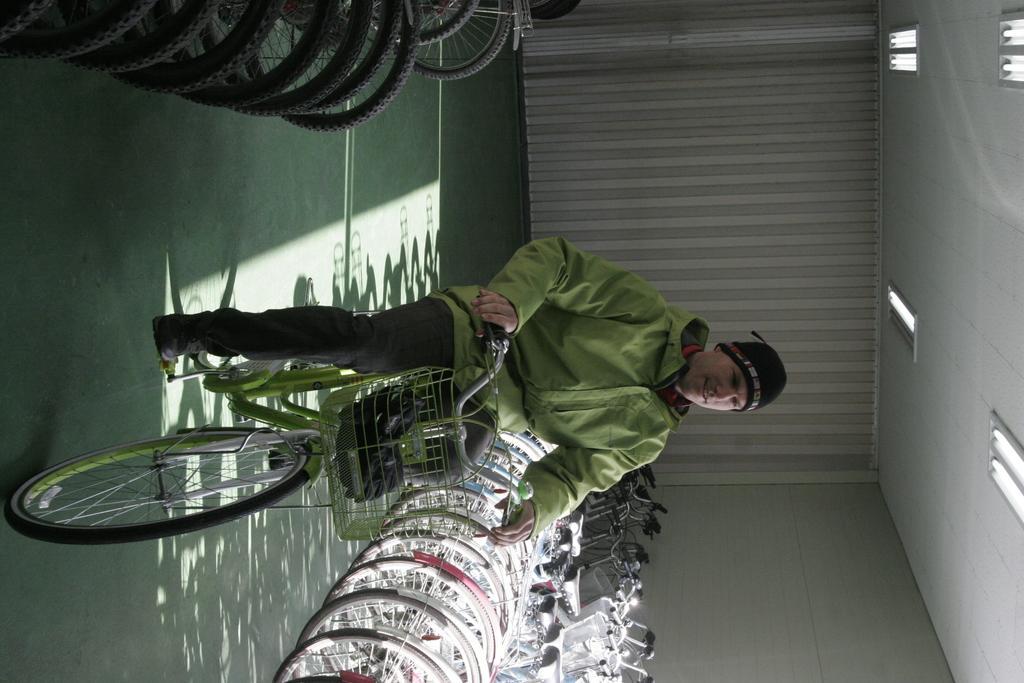Could you give a brief overview of what you see in this image? In the center of the image there is a person cycling on the mat. On both right and left side of the image there are cycles. In the background of the image there is a wall. On top of the image there are lights. 